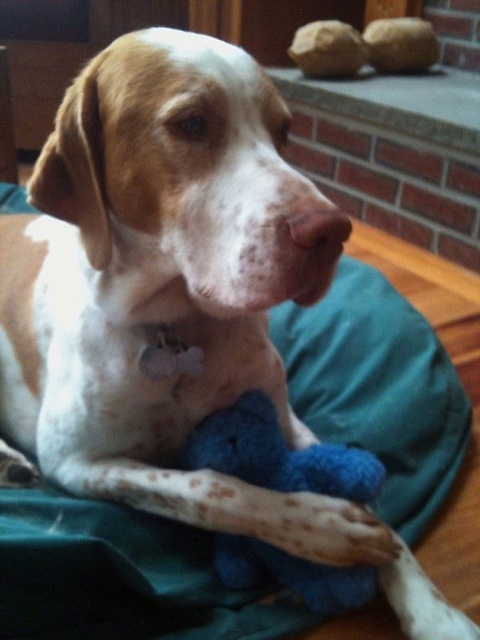Describe the objects in this image and their specific colors. I can see dog in black, gray, darkgray, and maroon tones and teddy bear in black, navy, blue, and darkblue tones in this image. 